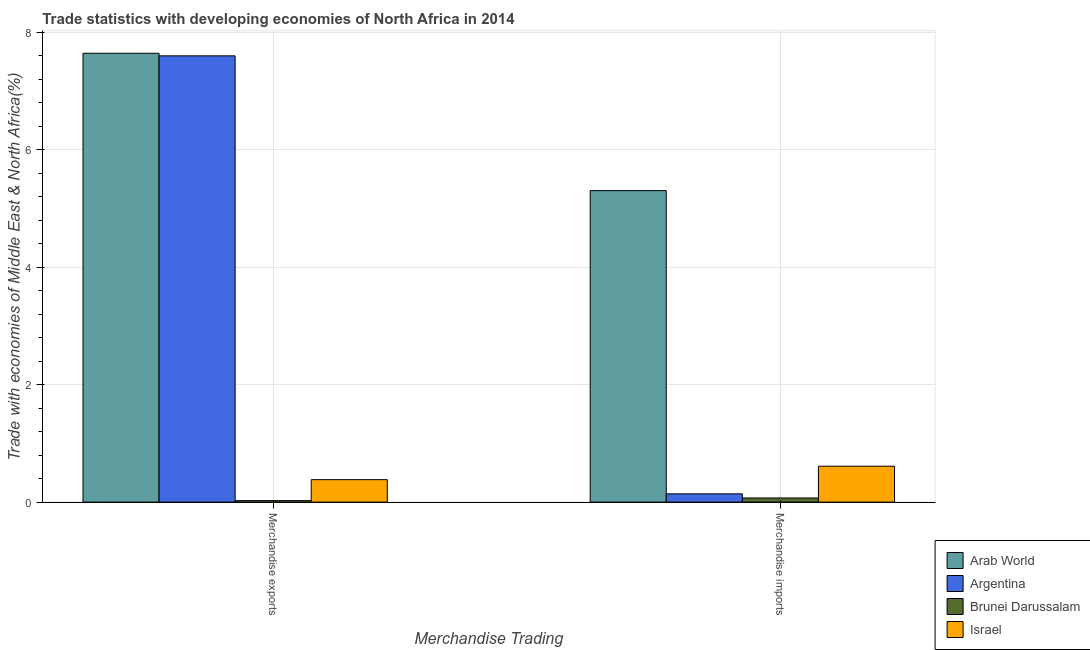How many different coloured bars are there?
Keep it short and to the point. 4. How many groups of bars are there?
Provide a succinct answer. 2. How many bars are there on the 1st tick from the left?
Ensure brevity in your answer.  4. How many bars are there on the 2nd tick from the right?
Your response must be concise. 4. What is the merchandise imports in Argentina?
Offer a terse response. 0.14. Across all countries, what is the maximum merchandise imports?
Offer a terse response. 5.3. Across all countries, what is the minimum merchandise exports?
Your answer should be very brief. 0.03. In which country was the merchandise exports maximum?
Your response must be concise. Arab World. In which country was the merchandise imports minimum?
Ensure brevity in your answer.  Brunei Darussalam. What is the total merchandise exports in the graph?
Offer a terse response. 15.64. What is the difference between the merchandise exports in Argentina and that in Brunei Darussalam?
Your response must be concise. 7.57. What is the difference between the merchandise exports in Argentina and the merchandise imports in Brunei Darussalam?
Ensure brevity in your answer.  7.52. What is the average merchandise exports per country?
Your answer should be very brief. 3.91. What is the difference between the merchandise exports and merchandise imports in Arab World?
Offer a terse response. 2.34. What is the ratio of the merchandise exports in Brunei Darussalam to that in Israel?
Ensure brevity in your answer.  0.07. What does the 2nd bar from the right in Merchandise exports represents?
Your answer should be compact. Brunei Darussalam. Are all the bars in the graph horizontal?
Keep it short and to the point. No. How many countries are there in the graph?
Give a very brief answer. 4. Does the graph contain grids?
Offer a terse response. Yes. How many legend labels are there?
Offer a very short reply. 4. How are the legend labels stacked?
Provide a short and direct response. Vertical. What is the title of the graph?
Your response must be concise. Trade statistics with developing economies of North Africa in 2014. Does "Pakistan" appear as one of the legend labels in the graph?
Offer a terse response. No. What is the label or title of the X-axis?
Provide a short and direct response. Merchandise Trading. What is the label or title of the Y-axis?
Provide a succinct answer. Trade with economies of Middle East & North Africa(%). What is the Trade with economies of Middle East & North Africa(%) in Arab World in Merchandise exports?
Your answer should be very brief. 7.64. What is the Trade with economies of Middle East & North Africa(%) in Argentina in Merchandise exports?
Your answer should be compact. 7.6. What is the Trade with economies of Middle East & North Africa(%) of Brunei Darussalam in Merchandise exports?
Ensure brevity in your answer.  0.03. What is the Trade with economies of Middle East & North Africa(%) in Israel in Merchandise exports?
Offer a terse response. 0.38. What is the Trade with economies of Middle East & North Africa(%) of Arab World in Merchandise imports?
Your answer should be very brief. 5.3. What is the Trade with economies of Middle East & North Africa(%) of Argentina in Merchandise imports?
Provide a succinct answer. 0.14. What is the Trade with economies of Middle East & North Africa(%) of Brunei Darussalam in Merchandise imports?
Your answer should be compact. 0.07. What is the Trade with economies of Middle East & North Africa(%) in Israel in Merchandise imports?
Offer a very short reply. 0.61. Across all Merchandise Trading, what is the maximum Trade with economies of Middle East & North Africa(%) of Arab World?
Offer a very short reply. 7.64. Across all Merchandise Trading, what is the maximum Trade with economies of Middle East & North Africa(%) in Argentina?
Provide a short and direct response. 7.6. Across all Merchandise Trading, what is the maximum Trade with economies of Middle East & North Africa(%) in Brunei Darussalam?
Provide a short and direct response. 0.07. Across all Merchandise Trading, what is the maximum Trade with economies of Middle East & North Africa(%) in Israel?
Your response must be concise. 0.61. Across all Merchandise Trading, what is the minimum Trade with economies of Middle East & North Africa(%) of Arab World?
Give a very brief answer. 5.3. Across all Merchandise Trading, what is the minimum Trade with economies of Middle East & North Africa(%) of Argentina?
Your response must be concise. 0.14. Across all Merchandise Trading, what is the minimum Trade with economies of Middle East & North Africa(%) in Brunei Darussalam?
Keep it short and to the point. 0.03. Across all Merchandise Trading, what is the minimum Trade with economies of Middle East & North Africa(%) of Israel?
Make the answer very short. 0.38. What is the total Trade with economies of Middle East & North Africa(%) in Arab World in the graph?
Make the answer very short. 12.94. What is the total Trade with economies of Middle East & North Africa(%) of Argentina in the graph?
Offer a very short reply. 7.74. What is the total Trade with economies of Middle East & North Africa(%) of Brunei Darussalam in the graph?
Offer a terse response. 0.1. What is the difference between the Trade with economies of Middle East & North Africa(%) of Arab World in Merchandise exports and that in Merchandise imports?
Ensure brevity in your answer.  2.34. What is the difference between the Trade with economies of Middle East & North Africa(%) of Argentina in Merchandise exports and that in Merchandise imports?
Provide a succinct answer. 7.45. What is the difference between the Trade with economies of Middle East & North Africa(%) of Brunei Darussalam in Merchandise exports and that in Merchandise imports?
Your response must be concise. -0.05. What is the difference between the Trade with economies of Middle East & North Africa(%) in Israel in Merchandise exports and that in Merchandise imports?
Offer a very short reply. -0.23. What is the difference between the Trade with economies of Middle East & North Africa(%) of Arab World in Merchandise exports and the Trade with economies of Middle East & North Africa(%) of Argentina in Merchandise imports?
Provide a short and direct response. 7.5. What is the difference between the Trade with economies of Middle East & North Africa(%) in Arab World in Merchandise exports and the Trade with economies of Middle East & North Africa(%) in Brunei Darussalam in Merchandise imports?
Give a very brief answer. 7.57. What is the difference between the Trade with economies of Middle East & North Africa(%) in Arab World in Merchandise exports and the Trade with economies of Middle East & North Africa(%) in Israel in Merchandise imports?
Make the answer very short. 7.03. What is the difference between the Trade with economies of Middle East & North Africa(%) of Argentina in Merchandise exports and the Trade with economies of Middle East & North Africa(%) of Brunei Darussalam in Merchandise imports?
Provide a succinct answer. 7.52. What is the difference between the Trade with economies of Middle East & North Africa(%) in Argentina in Merchandise exports and the Trade with economies of Middle East & North Africa(%) in Israel in Merchandise imports?
Offer a very short reply. 6.98. What is the difference between the Trade with economies of Middle East & North Africa(%) in Brunei Darussalam in Merchandise exports and the Trade with economies of Middle East & North Africa(%) in Israel in Merchandise imports?
Keep it short and to the point. -0.59. What is the average Trade with economies of Middle East & North Africa(%) of Arab World per Merchandise Trading?
Provide a succinct answer. 6.47. What is the average Trade with economies of Middle East & North Africa(%) of Argentina per Merchandise Trading?
Ensure brevity in your answer.  3.87. What is the average Trade with economies of Middle East & North Africa(%) in Brunei Darussalam per Merchandise Trading?
Your response must be concise. 0.05. What is the average Trade with economies of Middle East & North Africa(%) of Israel per Merchandise Trading?
Provide a short and direct response. 0.5. What is the difference between the Trade with economies of Middle East & North Africa(%) in Arab World and Trade with economies of Middle East & North Africa(%) in Argentina in Merchandise exports?
Offer a terse response. 0.04. What is the difference between the Trade with economies of Middle East & North Africa(%) in Arab World and Trade with economies of Middle East & North Africa(%) in Brunei Darussalam in Merchandise exports?
Your response must be concise. 7.61. What is the difference between the Trade with economies of Middle East & North Africa(%) of Arab World and Trade with economies of Middle East & North Africa(%) of Israel in Merchandise exports?
Your response must be concise. 7.26. What is the difference between the Trade with economies of Middle East & North Africa(%) in Argentina and Trade with economies of Middle East & North Africa(%) in Brunei Darussalam in Merchandise exports?
Provide a succinct answer. 7.57. What is the difference between the Trade with economies of Middle East & North Africa(%) in Argentina and Trade with economies of Middle East & North Africa(%) in Israel in Merchandise exports?
Offer a terse response. 7.21. What is the difference between the Trade with economies of Middle East & North Africa(%) in Brunei Darussalam and Trade with economies of Middle East & North Africa(%) in Israel in Merchandise exports?
Make the answer very short. -0.36. What is the difference between the Trade with economies of Middle East & North Africa(%) in Arab World and Trade with economies of Middle East & North Africa(%) in Argentina in Merchandise imports?
Your response must be concise. 5.16. What is the difference between the Trade with economies of Middle East & North Africa(%) in Arab World and Trade with economies of Middle East & North Africa(%) in Brunei Darussalam in Merchandise imports?
Your answer should be compact. 5.23. What is the difference between the Trade with economies of Middle East & North Africa(%) of Arab World and Trade with economies of Middle East & North Africa(%) of Israel in Merchandise imports?
Make the answer very short. 4.69. What is the difference between the Trade with economies of Middle East & North Africa(%) of Argentina and Trade with economies of Middle East & North Africa(%) of Brunei Darussalam in Merchandise imports?
Provide a short and direct response. 0.07. What is the difference between the Trade with economies of Middle East & North Africa(%) in Argentina and Trade with economies of Middle East & North Africa(%) in Israel in Merchandise imports?
Provide a succinct answer. -0.47. What is the difference between the Trade with economies of Middle East & North Africa(%) of Brunei Darussalam and Trade with economies of Middle East & North Africa(%) of Israel in Merchandise imports?
Ensure brevity in your answer.  -0.54. What is the ratio of the Trade with economies of Middle East & North Africa(%) of Arab World in Merchandise exports to that in Merchandise imports?
Your response must be concise. 1.44. What is the ratio of the Trade with economies of Middle East & North Africa(%) in Argentina in Merchandise exports to that in Merchandise imports?
Offer a very short reply. 53.8. What is the ratio of the Trade with economies of Middle East & North Africa(%) in Brunei Darussalam in Merchandise exports to that in Merchandise imports?
Give a very brief answer. 0.36. What is the ratio of the Trade with economies of Middle East & North Africa(%) in Israel in Merchandise exports to that in Merchandise imports?
Give a very brief answer. 0.63. What is the difference between the highest and the second highest Trade with economies of Middle East & North Africa(%) of Arab World?
Make the answer very short. 2.34. What is the difference between the highest and the second highest Trade with economies of Middle East & North Africa(%) of Argentina?
Provide a short and direct response. 7.45. What is the difference between the highest and the second highest Trade with economies of Middle East & North Africa(%) of Brunei Darussalam?
Offer a very short reply. 0.05. What is the difference between the highest and the second highest Trade with economies of Middle East & North Africa(%) of Israel?
Give a very brief answer. 0.23. What is the difference between the highest and the lowest Trade with economies of Middle East & North Africa(%) of Arab World?
Give a very brief answer. 2.34. What is the difference between the highest and the lowest Trade with economies of Middle East & North Africa(%) in Argentina?
Your answer should be very brief. 7.45. What is the difference between the highest and the lowest Trade with economies of Middle East & North Africa(%) of Brunei Darussalam?
Your answer should be very brief. 0.05. What is the difference between the highest and the lowest Trade with economies of Middle East & North Africa(%) in Israel?
Offer a very short reply. 0.23. 